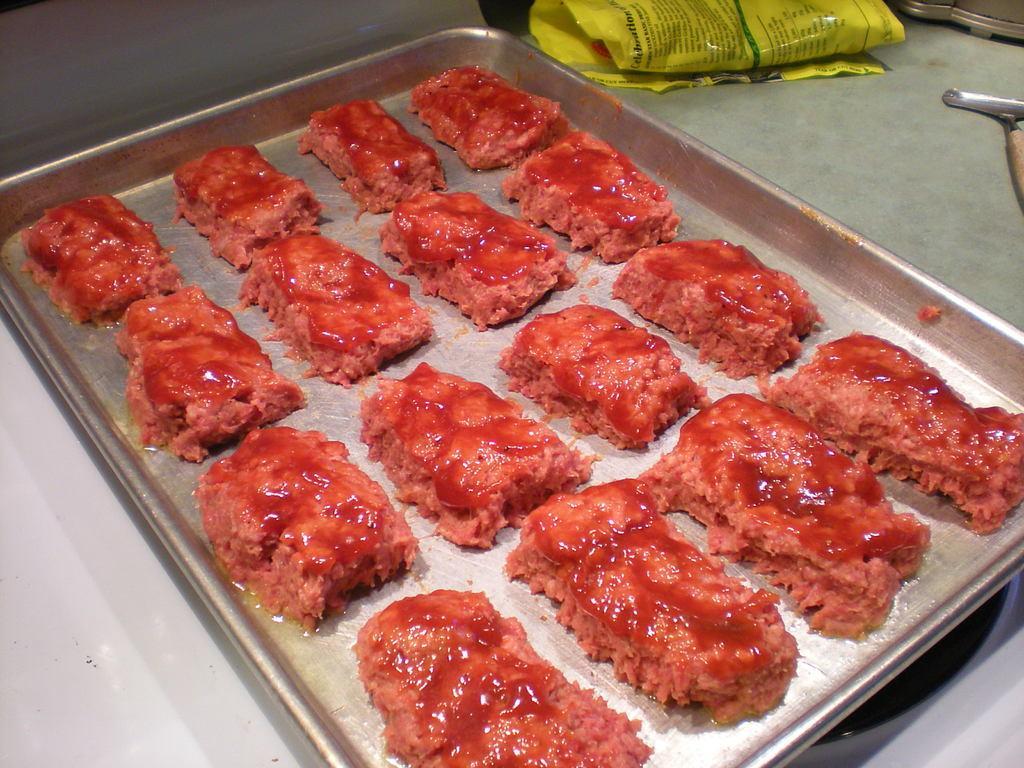Could you give a brief overview of what you see in this image? In this picture there is a food on the tray and there is a cover on the desk and there is a tray on the stove. 